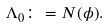<formula> <loc_0><loc_0><loc_500><loc_500>\Lambda _ { 0 } \colon = N ( \phi ) .</formula> 